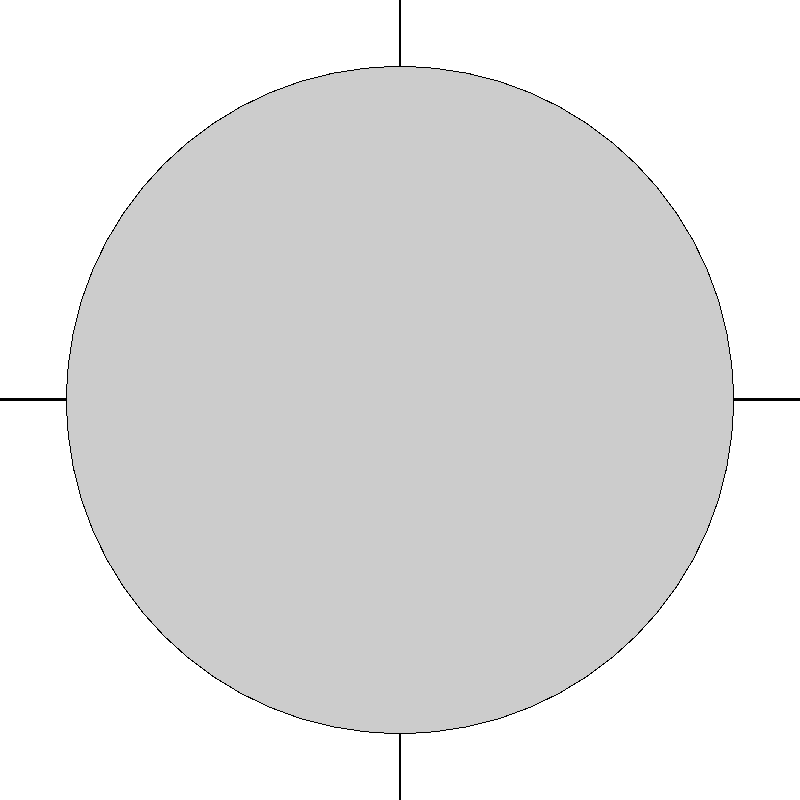As a tourist in McAllen, Texas, you notice the moon's appearance changes over time. Which phase of the moon would be most visible from McAllen during the early evening, based on the diagram? Let's analyze this step-by-step:

1. The diagram shows the Earth at the center, with the Sun to the right and McAllen (represented by "To McAllen") to the left.

2. The moon's orbit is shown around the Earth, with an arrow indicating its direction (counterclockwise).

3. The illuminated portion of the moon is always facing the Sun.

4. In the early evening, McAllen would be facing away from the Sun (as it's on the opposite side of Earth from the Sun in the diagram).

5. For the moon to be visible in the early evening sky from McAllen, it needs to be in the eastern part of the sky (to the right in this diagram, from McAllen's perspective).

6. The phase that would be most visible in this position would be when the moon is on the right side of Earth in this diagram.

7. At this position, the right half of the moon (from Earth's perspective) would be illuminated by the Sun.

8. This configuration corresponds to the First Quarter phase of the moon.
Answer: First Quarter 